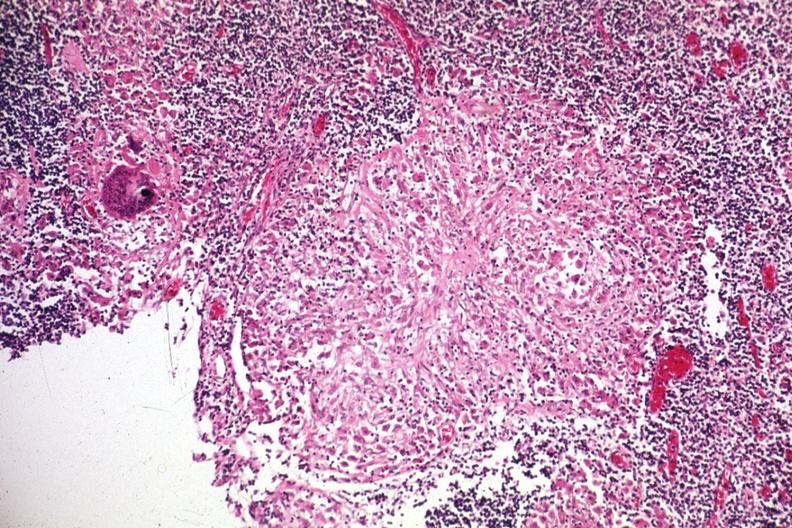does lymphoblastic lymphoma show granuloma?
Answer the question using a single word or phrase. No 